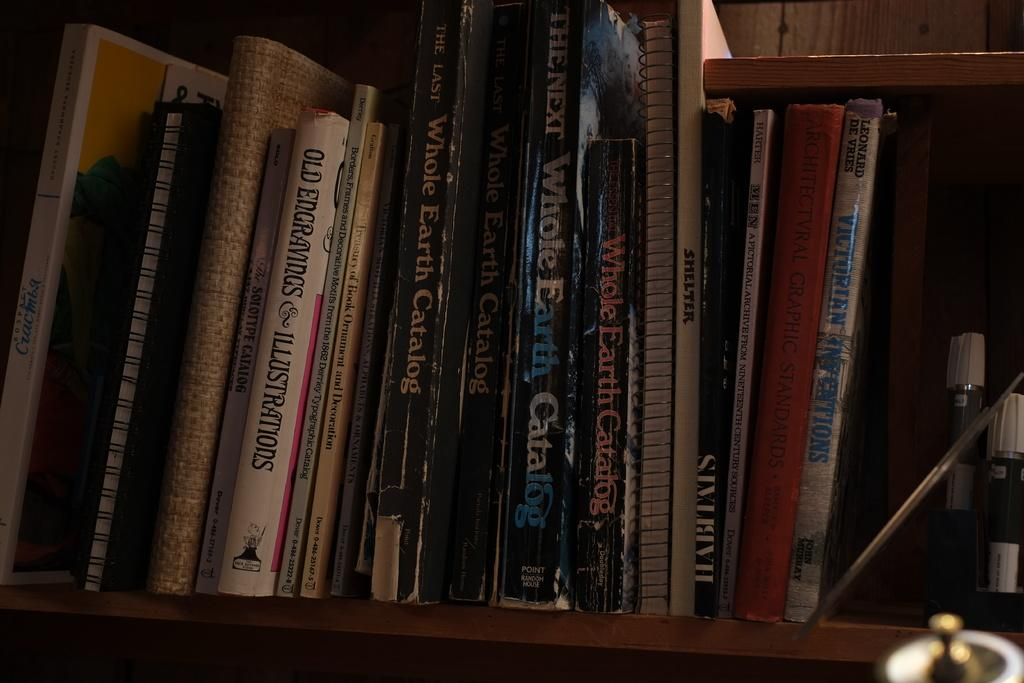Provide a one-sentence caption for the provided image. A SHELF WITH NOOKTBOOKS AND BOOKS, ONE BOOK IS THE WHOLE EARTH CATALOG. 